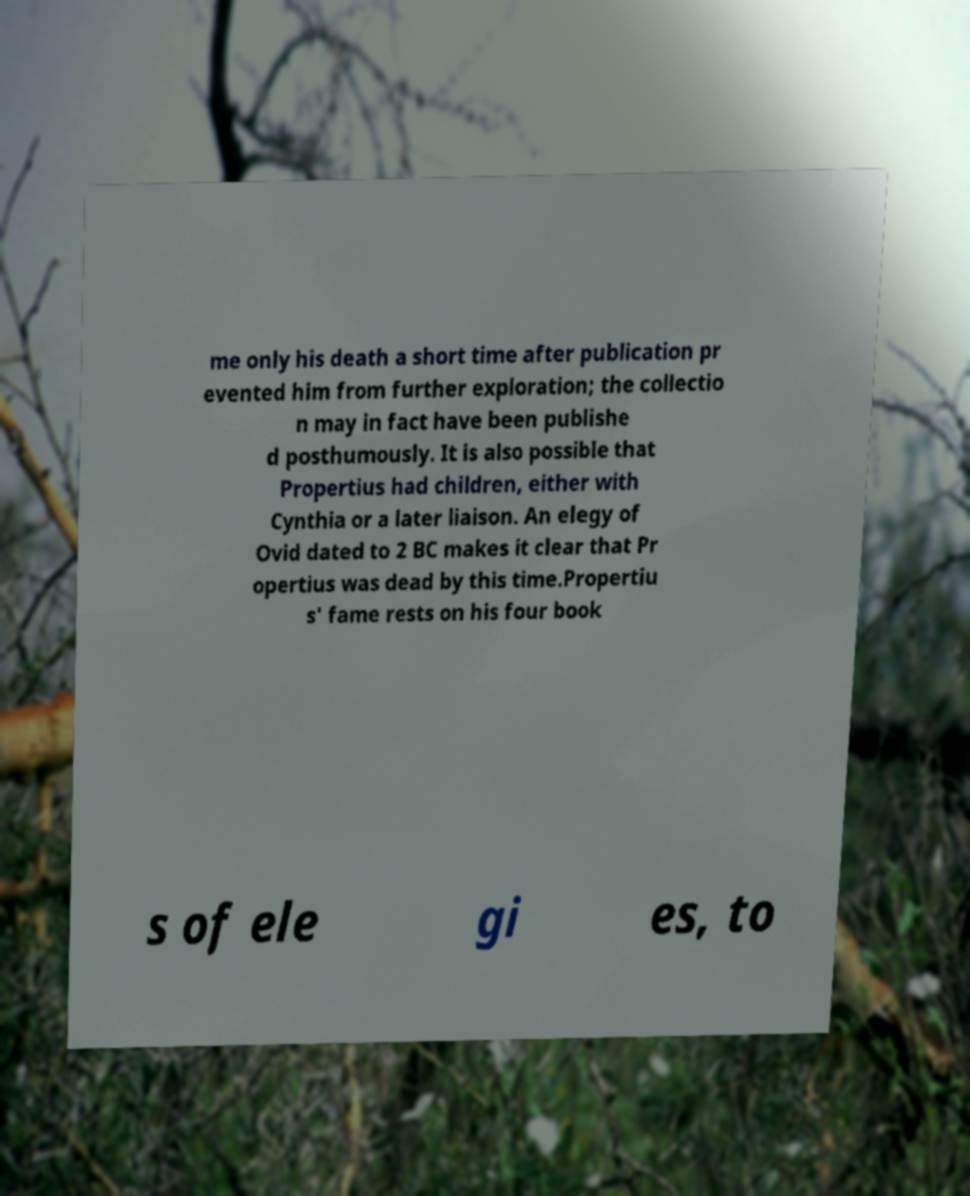For documentation purposes, I need the text within this image transcribed. Could you provide that? me only his death a short time after publication pr evented him from further exploration; the collectio n may in fact have been publishe d posthumously. It is also possible that Propertius had children, either with Cynthia or a later liaison. An elegy of Ovid dated to 2 BC makes it clear that Pr opertius was dead by this time.Propertiu s' fame rests on his four book s of ele gi es, to 